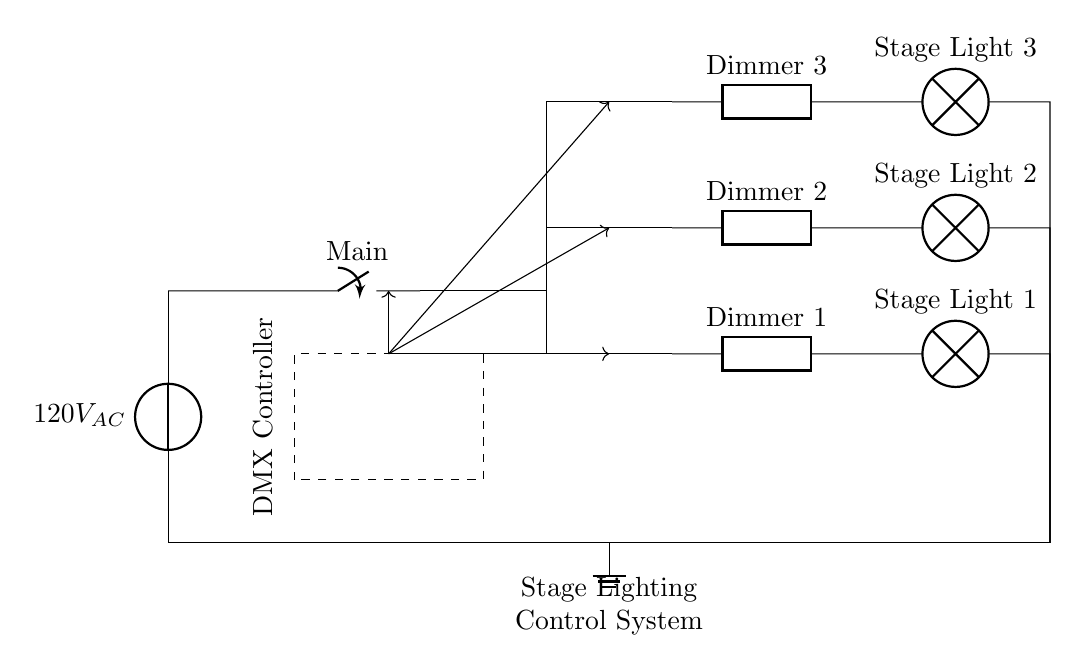What is the power source voltage? The power source voltage is labeled as 120V AC in the diagram, indicating it’s alternating current.
Answer: 120V AC What are the types of components used in the dimmer circuits? The dimmer circuits include generic components labeled as Dimmer 1, Dimmer 2, and Dimmer 3, connected to lamps.
Answer: Generic How many dimmers are present in the circuit? The circuit diagram shows three dimmers—Dimmer 1, Dimmer 2, and Dimmer 3—indicating there are three separate dimming channels for lights.
Answer: Three What does the dashed rectangle represent? The dashed rectangle in the diagram represents the DMX Controller, which is responsible for controlling the dimmers and thus the stage lights.
Answer: DMX Controller Which component directly connects the power source to the dimmer circuits? The main switch is the component that controls the connection between the power source and the dimmer circuits.
Answer: Main switch How is the DMX Controller connected to the dimmer circuits? The DMX Controller outputs signals to each of the three dimmers; it's connected with arrows indicating control flow to Dimmer 1, Dimmer 2, and Dimmer 3.
Answer: Arrows 